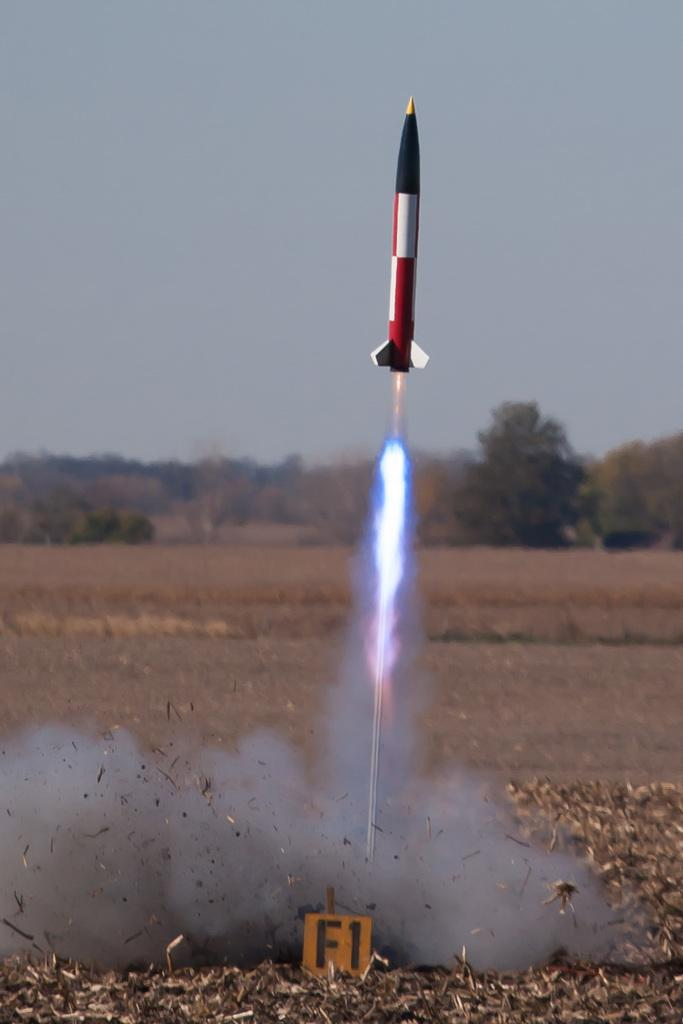What is happening in the image? There is a rocket being fired in the image. Where is the rocket going? The rocket is going up into the sky. What is the ground covered with in the image? The ground is filled with dry leaves. What can be seen in the background of the image? There are trees in the background of the image. Can you see a horse pulling a window in the image? No, there is no horse or window present in the image. 